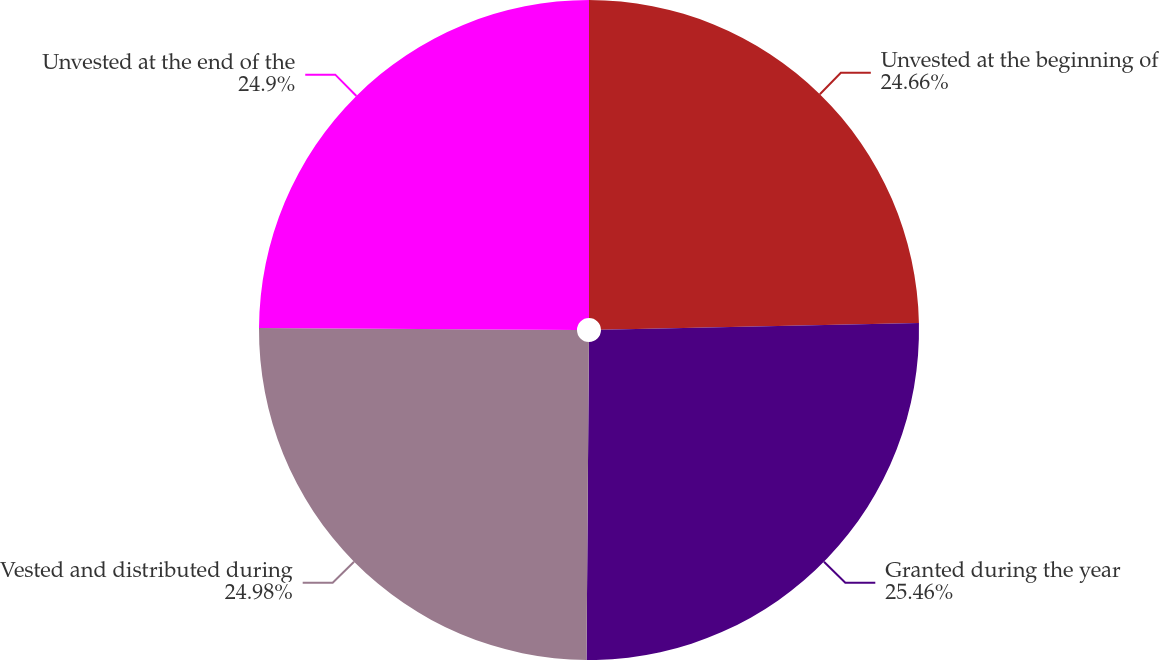Convert chart to OTSL. <chart><loc_0><loc_0><loc_500><loc_500><pie_chart><fcel>Unvested at the beginning of<fcel>Granted during the year<fcel>Vested and distributed during<fcel>Unvested at the end of the<nl><fcel>24.66%<fcel>25.46%<fcel>24.98%<fcel>24.9%<nl></chart> 